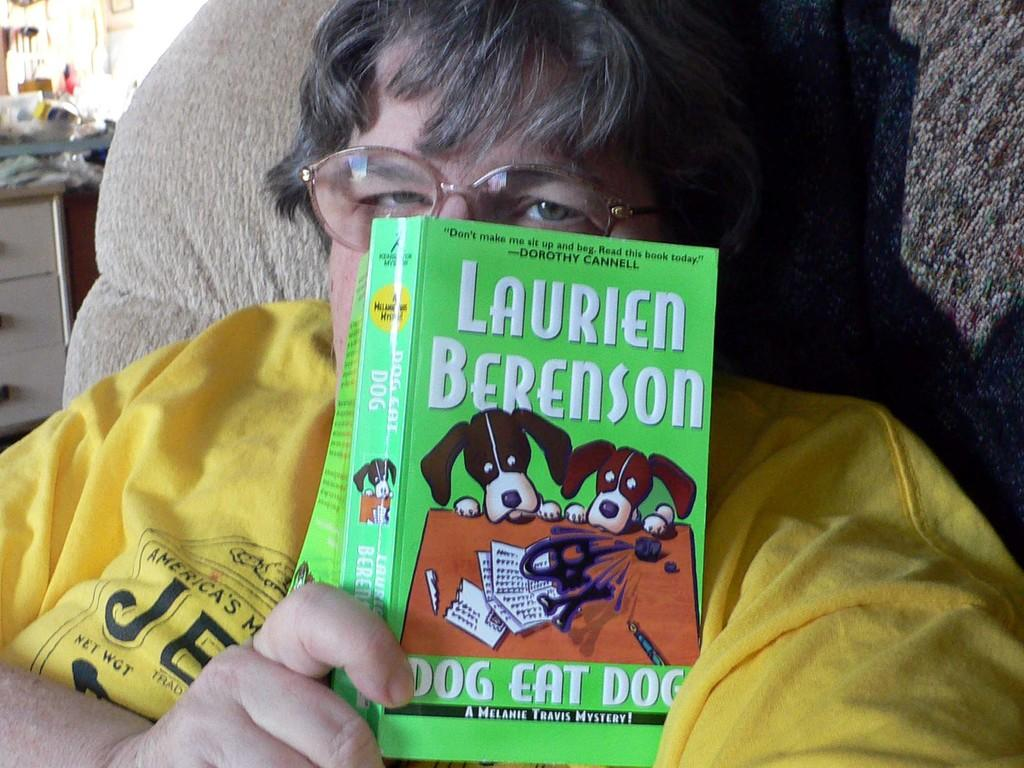What is the person in the image doing? There is a person sitting in the image. What is the person wearing? The person is wearing a yellow t-shirt. What is the person holding in their hand? The person is holding a book in their hand. What can be seen in the background of the image? There is a cupboard visible in the background of the image. What is on the cupboard? There are items on the cupboard. What type of territory is the monkey claiming in the image? There is no monkey present in the image, and therefore no territory is being claimed. How tall are the giants in the image? There are no giants present in the image. 